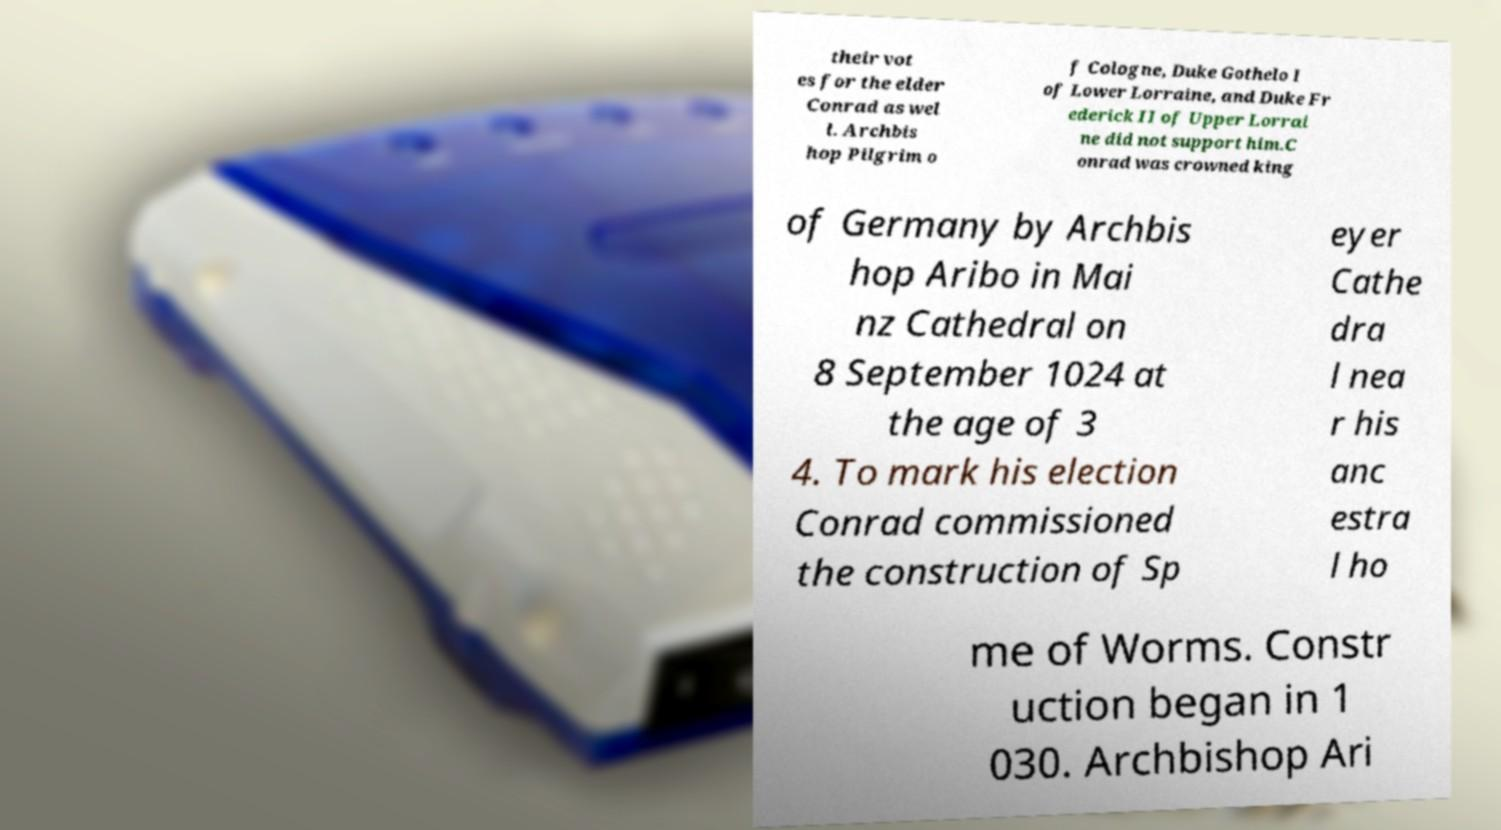What messages or text are displayed in this image? I need them in a readable, typed format. their vot es for the elder Conrad as wel l. Archbis hop Pilgrim o f Cologne, Duke Gothelo I of Lower Lorraine, and Duke Fr ederick II of Upper Lorrai ne did not support him.C onrad was crowned king of Germany by Archbis hop Aribo in Mai nz Cathedral on 8 September 1024 at the age of 3 4. To mark his election Conrad commissioned the construction of Sp eyer Cathe dra l nea r his anc estra l ho me of Worms. Constr uction began in 1 030. Archbishop Ari 